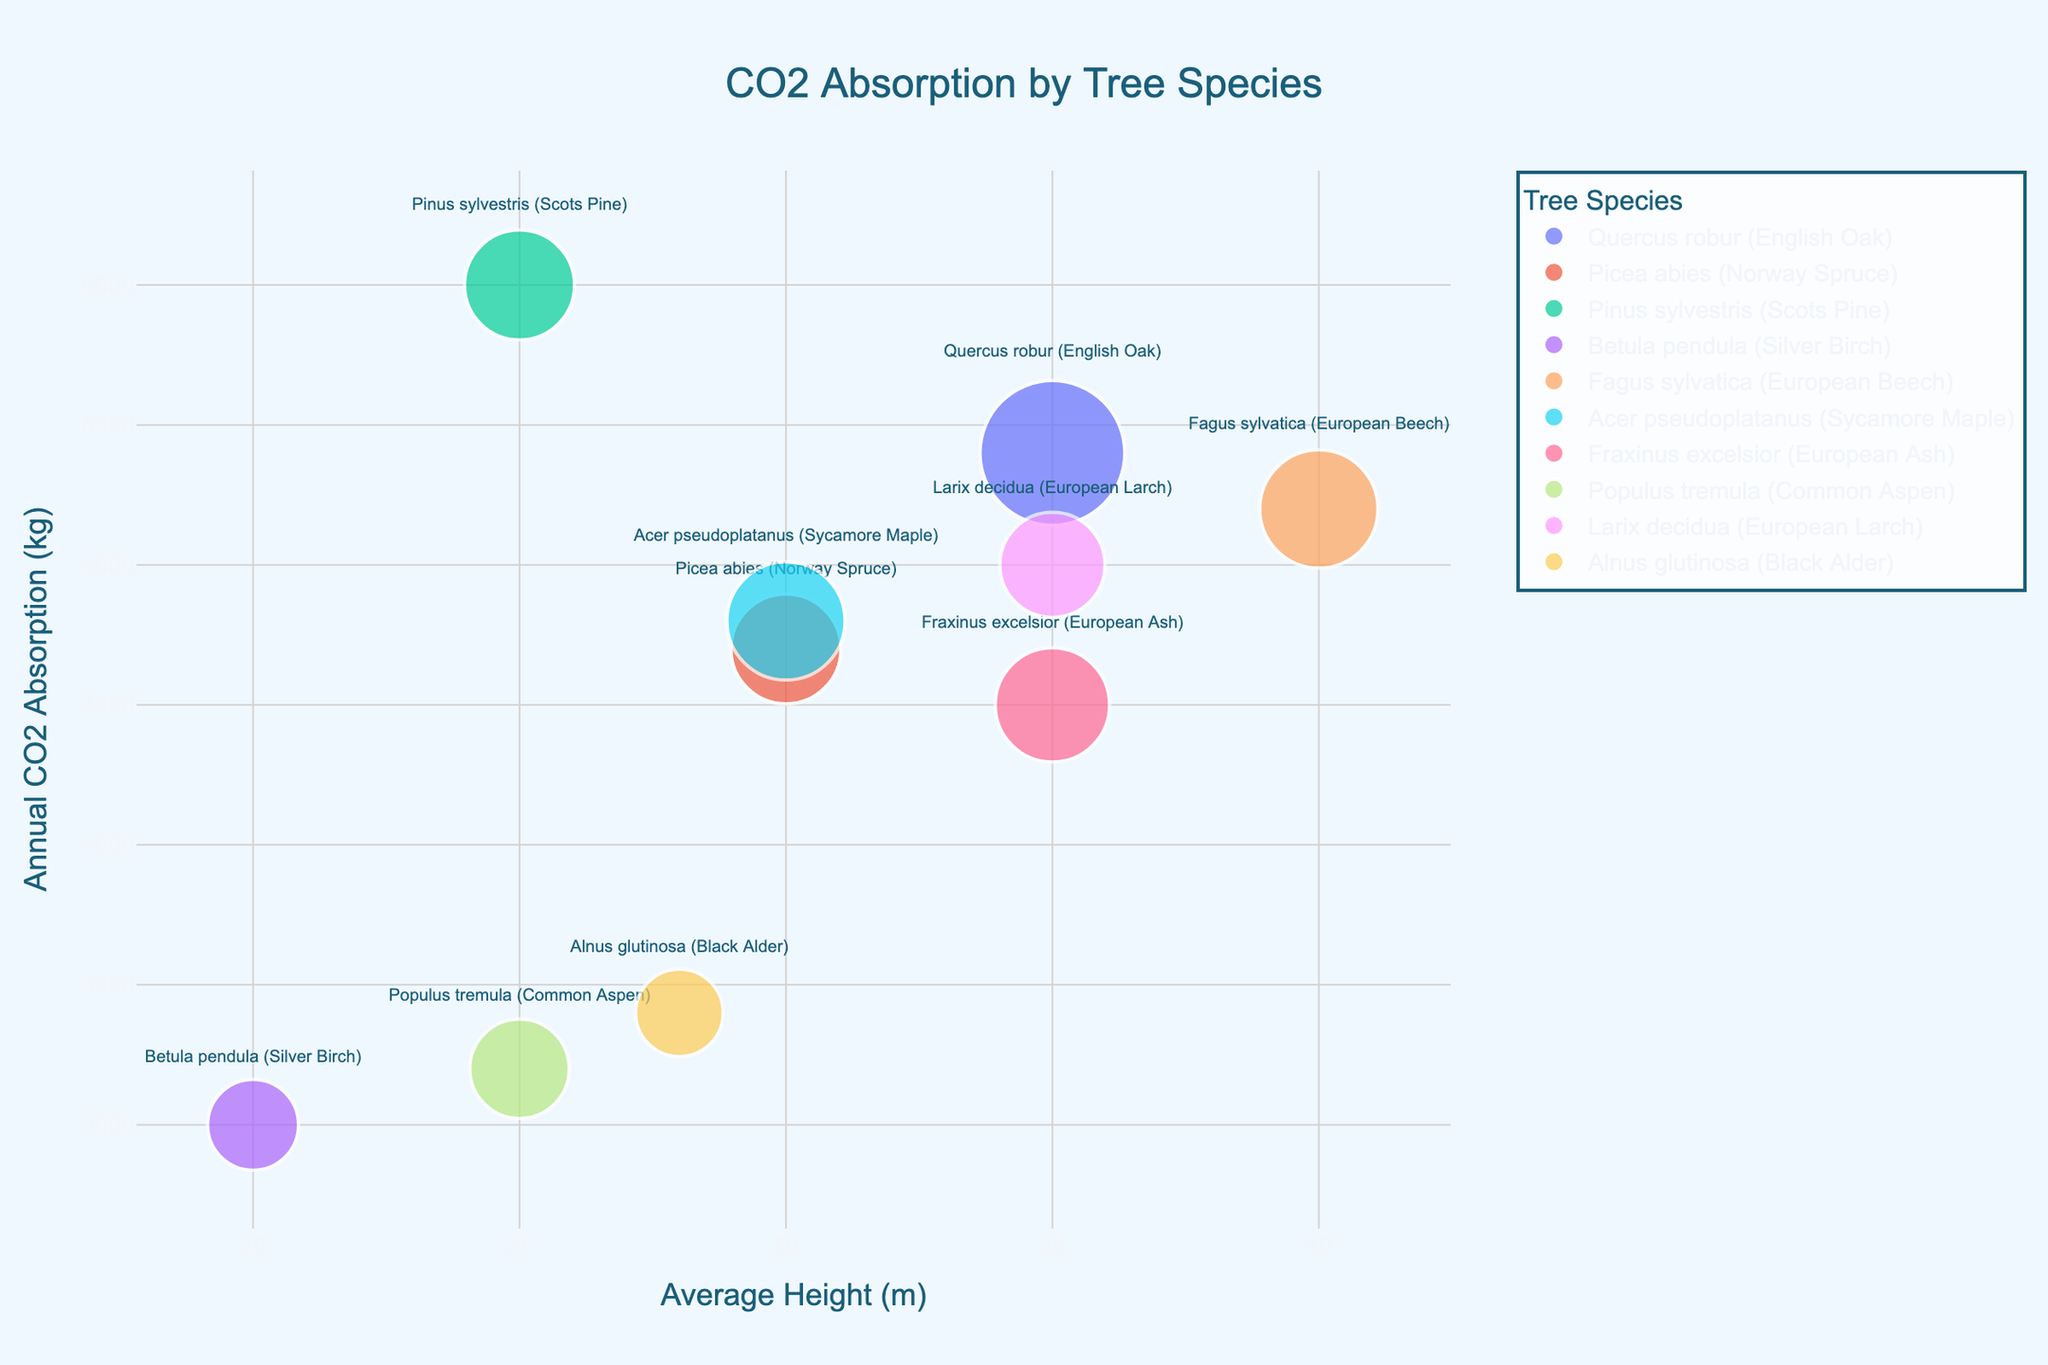What is the title of the figure? The title is prominently displayed at the top center of the figure. The figure's title helps viewers understand the content at a glance.
Answer: CO2 Absorption by Tree Species Which axis represents the average height of the tree species? The average height of the tree species is shown on the horizontal (x) axis. It helps viewers identify the average height values from left to right.
Answer: x-axis Which species has the highest annual CO2 absorption rate? To find this, look for the highest position on the vertical (y) axis. The tree species name is also displayed as text near each bubble.
Answer: Pinus sylvestris (Scots Pine) What is the average height of Quercus robur (English Oak)? Locate the bubble labeled "Quercus robur (English Oak)" and check its position on the x-axis, which represents the average height.
Answer: 35 meters Compare the CO2 absorption rate of Picea abies (Norway Spruce) and Pinus sylvestris (Scots Pine). Which absorbs more? Find the positions of both bubbles on the y-axis and compare their heights. The higher position represents a greater CO2 absorption rate.
Answer: Pinus sylvestris (Scots Pine) Which tree species has the longest lifespan? Bubble size encodes lifespan, so look for the largest bubble. Hover over or note the text annotation for the species name.
Answer: Quercus robur (English Oak) Which species has both an average height of 40 meters and high CO2 absorption rate? First, identify the bubble around the 40-meter mark on the x-axis, then check its y-position for a high CO2 absorption rate and read the species label.
Answer: Fagus sylvatica (European Beech) What is the approximate CO2 absorption rate difference between Betula pendula (Silver Birch) and Fraxinus excelsior (European Ash)? Identify the y-axis positions of both species' bubbles and subtract the lower value from the higher value. Betula pendula is at 3000 kg and Fraxinus excelsior is at 4500 kg.
Answer: 1500 kg How many tree species have an average height of exactly 35 meters? Verify the bubbles that line up vertically with the 35-meter mark on the x-axis and identify the count.
Answer: 3 species Which species has the smallest bubble? Does it correspond to the shortest or longest lifespan? Identify the smallest bubble in terms of size, then hover over it or note the label to find the lifespan value. The smallest bubble corresponds to Alnus glutinosa (Black Alder).
Answer: Alnus glutinosa (Black Alder) corresponds to the shortest lifespan 